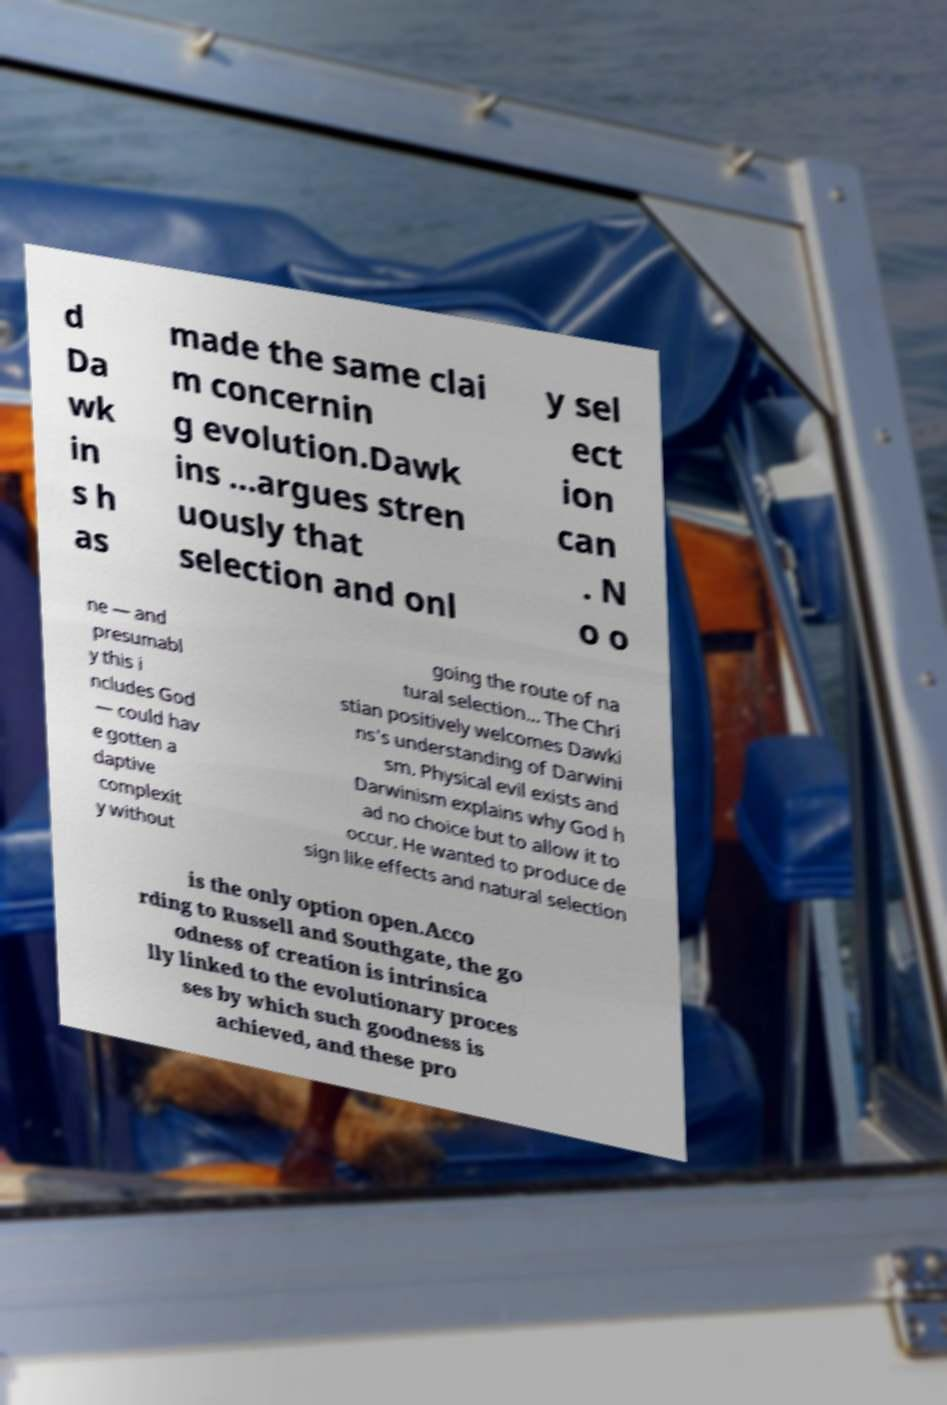Please read and relay the text visible in this image. What does it say? d Da wk in s h as made the same clai m concernin g evolution.Dawk ins ...argues stren uously that selection and onl y sel ect ion can . N o o ne — and presumabl y this i ncludes God — could hav e gotten a daptive complexit y without going the route of na tural selection... The Chri stian positively welcomes Dawki ns's understanding of Darwini sm. Physical evil exists and Darwinism explains why God h ad no choice but to allow it to occur. He wanted to produce de sign like effects and natural selection is the only option open.Acco rding to Russell and Southgate, the go odness of creation is intrinsica lly linked to the evolutionary proces ses by which such goodness is achieved, and these pro 